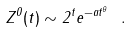<formula> <loc_0><loc_0><loc_500><loc_500>Z ^ { 0 } ( t ) \sim 2 ^ { t } e ^ { - a t ^ { \theta } } \ .</formula> 